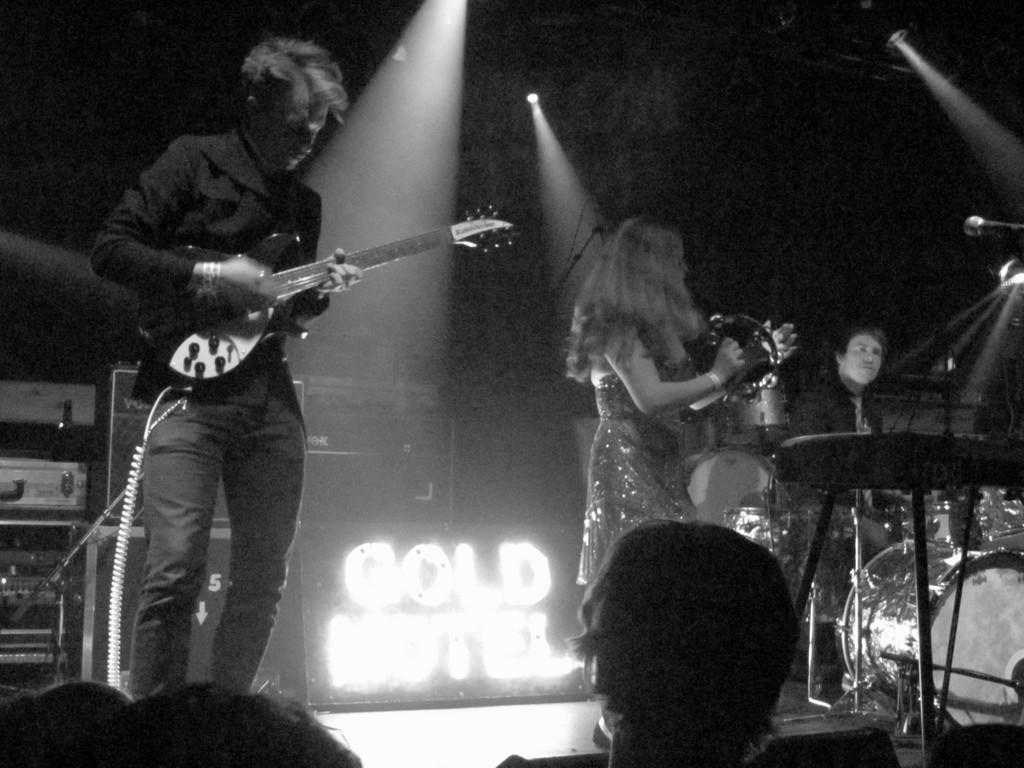Could you give a brief overview of what you see in this image? A black and white picture. These two persons are standing on stage and playing musical instruments. On top there are focusing lights. 